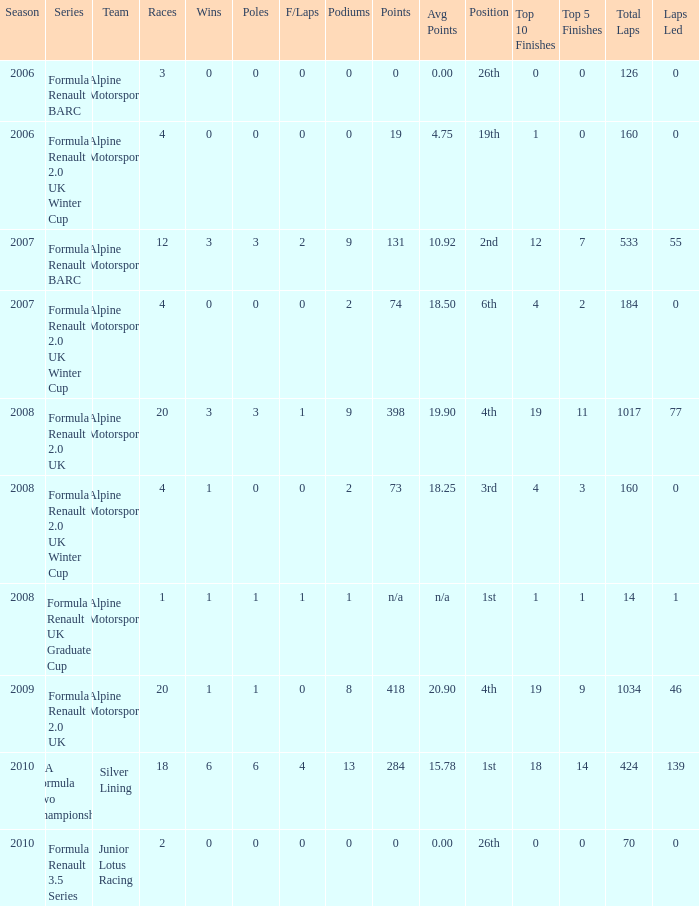Which races accomplished 0 fastest laps and 1 pole position? 20.0. 